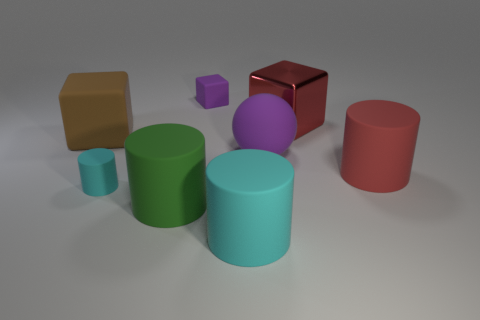How many other objects are the same size as the green object?
Make the answer very short. 5. There is a cylinder that is to the right of the cyan rubber cylinder on the right side of the small block; what is it made of?
Your response must be concise. Rubber. There is a brown matte cube; is it the same size as the cube that is to the right of the rubber sphere?
Provide a succinct answer. Yes. Are there any small matte objects of the same color as the tiny block?
Offer a terse response. No. What number of small objects are purple rubber objects or red rubber cylinders?
Offer a very short reply. 1. What number of cyan objects are there?
Provide a short and direct response. 2. There is a large cylinder right of the large shiny block; what is it made of?
Make the answer very short. Rubber. There is a large matte cube; are there any tiny purple things in front of it?
Ensure brevity in your answer.  No. Do the green rubber object and the rubber sphere have the same size?
Give a very brief answer. Yes. How many big red blocks have the same material as the tiny purple cube?
Your answer should be very brief. 0. 